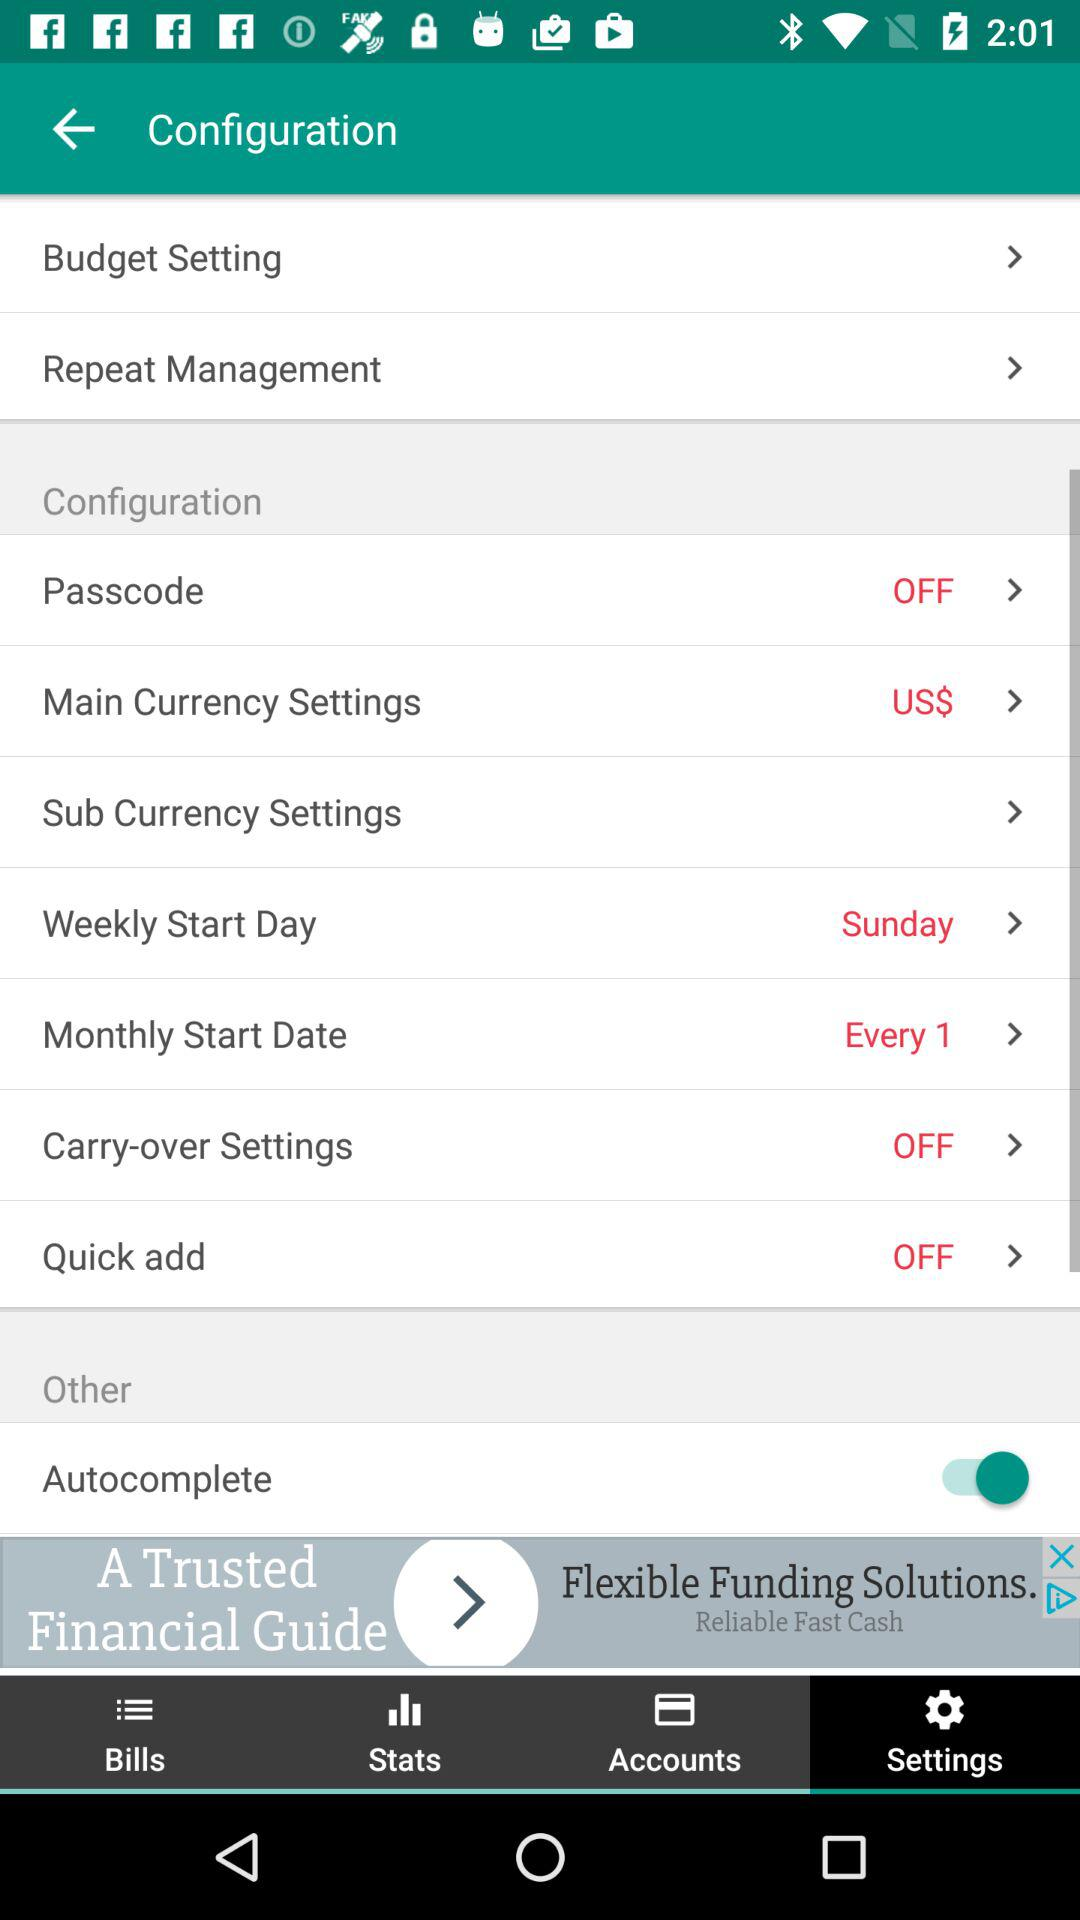What is the status of "Passcode"? "Passcode" is turned off. 